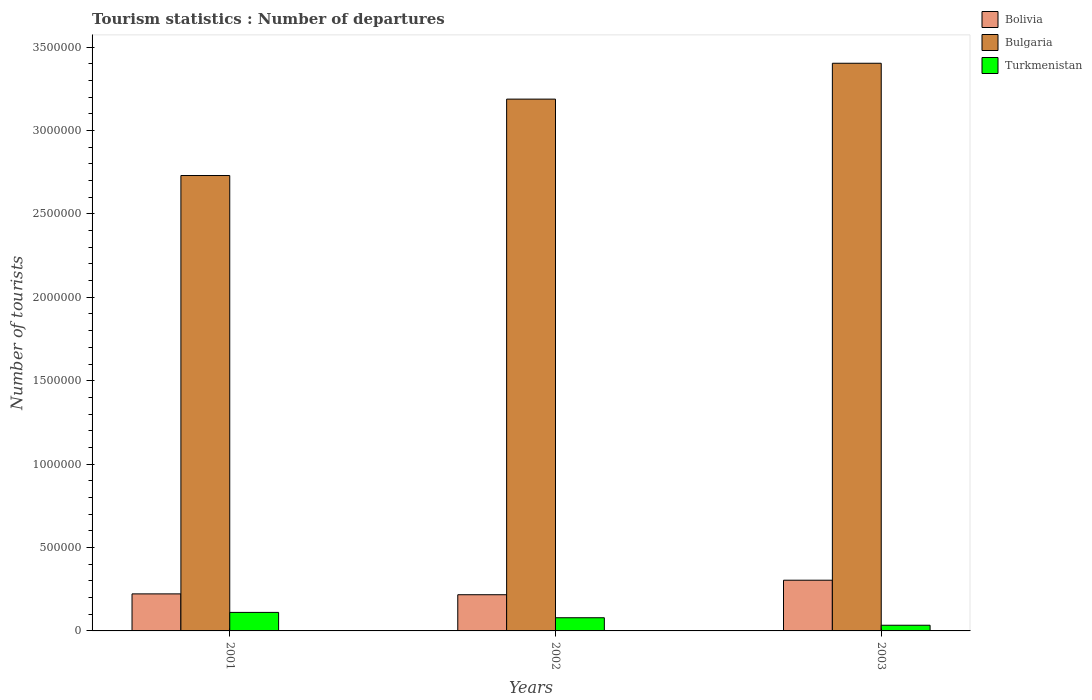How many groups of bars are there?
Ensure brevity in your answer.  3. Are the number of bars per tick equal to the number of legend labels?
Your response must be concise. Yes. How many bars are there on the 1st tick from the right?
Keep it short and to the point. 3. What is the number of tourist departures in Bulgaria in 2003?
Provide a short and direct response. 3.40e+06. Across all years, what is the maximum number of tourist departures in Bolivia?
Your answer should be very brief. 3.04e+05. Across all years, what is the minimum number of tourist departures in Bulgaria?
Provide a succinct answer. 2.73e+06. In which year was the number of tourist departures in Bolivia maximum?
Make the answer very short. 2003. In which year was the number of tourist departures in Turkmenistan minimum?
Offer a very short reply. 2003. What is the total number of tourist departures in Bolivia in the graph?
Give a very brief answer. 7.43e+05. What is the difference between the number of tourist departures in Bulgaria in 2001 and that in 2002?
Keep it short and to the point. -4.58e+05. What is the difference between the number of tourist departures in Bolivia in 2003 and the number of tourist departures in Turkmenistan in 2001?
Provide a short and direct response. 1.93e+05. What is the average number of tourist departures in Bulgaria per year?
Your answer should be very brief. 3.11e+06. In the year 2002, what is the difference between the number of tourist departures in Bolivia and number of tourist departures in Bulgaria?
Your answer should be very brief. -2.97e+06. In how many years, is the number of tourist departures in Bulgaria greater than 1100000?
Your response must be concise. 3. What is the ratio of the number of tourist departures in Bolivia in 2001 to that in 2003?
Offer a terse response. 0.73. Is the number of tourist departures in Turkmenistan in 2001 less than that in 2003?
Your answer should be compact. No. Is the difference between the number of tourist departures in Bolivia in 2002 and 2003 greater than the difference between the number of tourist departures in Bulgaria in 2002 and 2003?
Offer a very short reply. Yes. What is the difference between the highest and the second highest number of tourist departures in Turkmenistan?
Offer a terse response. 3.20e+04. What is the difference between the highest and the lowest number of tourist departures in Bulgaria?
Keep it short and to the point. 6.73e+05. What does the 1st bar from the left in 2002 represents?
Keep it short and to the point. Bolivia. What does the 2nd bar from the right in 2003 represents?
Provide a short and direct response. Bulgaria. Is it the case that in every year, the sum of the number of tourist departures in Bolivia and number of tourist departures in Turkmenistan is greater than the number of tourist departures in Bulgaria?
Your response must be concise. No. What is the difference between two consecutive major ticks on the Y-axis?
Offer a very short reply. 5.00e+05. Does the graph contain any zero values?
Give a very brief answer. No. How many legend labels are there?
Your response must be concise. 3. How are the legend labels stacked?
Provide a short and direct response. Vertical. What is the title of the graph?
Offer a terse response. Tourism statistics : Number of departures. Does "Croatia" appear as one of the legend labels in the graph?
Make the answer very short. No. What is the label or title of the X-axis?
Give a very brief answer. Years. What is the label or title of the Y-axis?
Ensure brevity in your answer.  Number of tourists. What is the Number of tourists of Bolivia in 2001?
Your response must be concise. 2.22e+05. What is the Number of tourists in Bulgaria in 2001?
Offer a very short reply. 2.73e+06. What is the Number of tourists in Turkmenistan in 2001?
Keep it short and to the point. 1.11e+05. What is the Number of tourists in Bolivia in 2002?
Offer a very short reply. 2.17e+05. What is the Number of tourists in Bulgaria in 2002?
Ensure brevity in your answer.  3.19e+06. What is the Number of tourists in Turkmenistan in 2002?
Make the answer very short. 7.90e+04. What is the Number of tourists in Bolivia in 2003?
Ensure brevity in your answer.  3.04e+05. What is the Number of tourists of Bulgaria in 2003?
Your response must be concise. 3.40e+06. What is the Number of tourists in Turkmenistan in 2003?
Provide a short and direct response. 3.40e+04. Across all years, what is the maximum Number of tourists in Bolivia?
Your response must be concise. 3.04e+05. Across all years, what is the maximum Number of tourists of Bulgaria?
Provide a succinct answer. 3.40e+06. Across all years, what is the maximum Number of tourists of Turkmenistan?
Keep it short and to the point. 1.11e+05. Across all years, what is the minimum Number of tourists of Bolivia?
Provide a succinct answer. 2.17e+05. Across all years, what is the minimum Number of tourists in Bulgaria?
Keep it short and to the point. 2.73e+06. Across all years, what is the minimum Number of tourists in Turkmenistan?
Your answer should be very brief. 3.40e+04. What is the total Number of tourists in Bolivia in the graph?
Your answer should be very brief. 7.43e+05. What is the total Number of tourists of Bulgaria in the graph?
Offer a very short reply. 9.32e+06. What is the total Number of tourists of Turkmenistan in the graph?
Provide a succinct answer. 2.24e+05. What is the difference between the Number of tourists of Bulgaria in 2001 and that in 2002?
Ensure brevity in your answer.  -4.58e+05. What is the difference between the Number of tourists of Turkmenistan in 2001 and that in 2002?
Offer a terse response. 3.20e+04. What is the difference between the Number of tourists of Bolivia in 2001 and that in 2003?
Keep it short and to the point. -8.20e+04. What is the difference between the Number of tourists in Bulgaria in 2001 and that in 2003?
Give a very brief answer. -6.73e+05. What is the difference between the Number of tourists in Turkmenistan in 2001 and that in 2003?
Keep it short and to the point. 7.70e+04. What is the difference between the Number of tourists in Bolivia in 2002 and that in 2003?
Your answer should be very brief. -8.70e+04. What is the difference between the Number of tourists in Bulgaria in 2002 and that in 2003?
Keep it short and to the point. -2.15e+05. What is the difference between the Number of tourists in Turkmenistan in 2002 and that in 2003?
Provide a short and direct response. 4.50e+04. What is the difference between the Number of tourists of Bolivia in 2001 and the Number of tourists of Bulgaria in 2002?
Ensure brevity in your answer.  -2.97e+06. What is the difference between the Number of tourists of Bolivia in 2001 and the Number of tourists of Turkmenistan in 2002?
Give a very brief answer. 1.43e+05. What is the difference between the Number of tourists in Bulgaria in 2001 and the Number of tourists in Turkmenistan in 2002?
Give a very brief answer. 2.65e+06. What is the difference between the Number of tourists of Bolivia in 2001 and the Number of tourists of Bulgaria in 2003?
Keep it short and to the point. -3.18e+06. What is the difference between the Number of tourists in Bolivia in 2001 and the Number of tourists in Turkmenistan in 2003?
Your answer should be very brief. 1.88e+05. What is the difference between the Number of tourists of Bulgaria in 2001 and the Number of tourists of Turkmenistan in 2003?
Give a very brief answer. 2.70e+06. What is the difference between the Number of tourists of Bolivia in 2002 and the Number of tourists of Bulgaria in 2003?
Give a very brief answer. -3.19e+06. What is the difference between the Number of tourists in Bolivia in 2002 and the Number of tourists in Turkmenistan in 2003?
Offer a terse response. 1.83e+05. What is the difference between the Number of tourists of Bulgaria in 2002 and the Number of tourists of Turkmenistan in 2003?
Your answer should be very brief. 3.15e+06. What is the average Number of tourists in Bolivia per year?
Your response must be concise. 2.48e+05. What is the average Number of tourists of Bulgaria per year?
Offer a terse response. 3.11e+06. What is the average Number of tourists in Turkmenistan per year?
Give a very brief answer. 7.47e+04. In the year 2001, what is the difference between the Number of tourists in Bolivia and Number of tourists in Bulgaria?
Your response must be concise. -2.51e+06. In the year 2001, what is the difference between the Number of tourists in Bolivia and Number of tourists in Turkmenistan?
Ensure brevity in your answer.  1.11e+05. In the year 2001, what is the difference between the Number of tourists in Bulgaria and Number of tourists in Turkmenistan?
Provide a succinct answer. 2.62e+06. In the year 2002, what is the difference between the Number of tourists in Bolivia and Number of tourists in Bulgaria?
Make the answer very short. -2.97e+06. In the year 2002, what is the difference between the Number of tourists of Bolivia and Number of tourists of Turkmenistan?
Provide a succinct answer. 1.38e+05. In the year 2002, what is the difference between the Number of tourists of Bulgaria and Number of tourists of Turkmenistan?
Give a very brief answer. 3.11e+06. In the year 2003, what is the difference between the Number of tourists in Bolivia and Number of tourists in Bulgaria?
Keep it short and to the point. -3.10e+06. In the year 2003, what is the difference between the Number of tourists in Bulgaria and Number of tourists in Turkmenistan?
Provide a short and direct response. 3.37e+06. What is the ratio of the Number of tourists of Bolivia in 2001 to that in 2002?
Your response must be concise. 1.02. What is the ratio of the Number of tourists in Bulgaria in 2001 to that in 2002?
Your answer should be compact. 0.86. What is the ratio of the Number of tourists in Turkmenistan in 2001 to that in 2002?
Make the answer very short. 1.41. What is the ratio of the Number of tourists in Bolivia in 2001 to that in 2003?
Offer a terse response. 0.73. What is the ratio of the Number of tourists in Bulgaria in 2001 to that in 2003?
Provide a succinct answer. 0.8. What is the ratio of the Number of tourists in Turkmenistan in 2001 to that in 2003?
Offer a terse response. 3.26. What is the ratio of the Number of tourists of Bolivia in 2002 to that in 2003?
Offer a terse response. 0.71. What is the ratio of the Number of tourists in Bulgaria in 2002 to that in 2003?
Offer a terse response. 0.94. What is the ratio of the Number of tourists in Turkmenistan in 2002 to that in 2003?
Your answer should be compact. 2.32. What is the difference between the highest and the second highest Number of tourists in Bolivia?
Ensure brevity in your answer.  8.20e+04. What is the difference between the highest and the second highest Number of tourists of Bulgaria?
Provide a succinct answer. 2.15e+05. What is the difference between the highest and the second highest Number of tourists of Turkmenistan?
Your answer should be compact. 3.20e+04. What is the difference between the highest and the lowest Number of tourists in Bolivia?
Provide a short and direct response. 8.70e+04. What is the difference between the highest and the lowest Number of tourists of Bulgaria?
Give a very brief answer. 6.73e+05. What is the difference between the highest and the lowest Number of tourists of Turkmenistan?
Your answer should be very brief. 7.70e+04. 